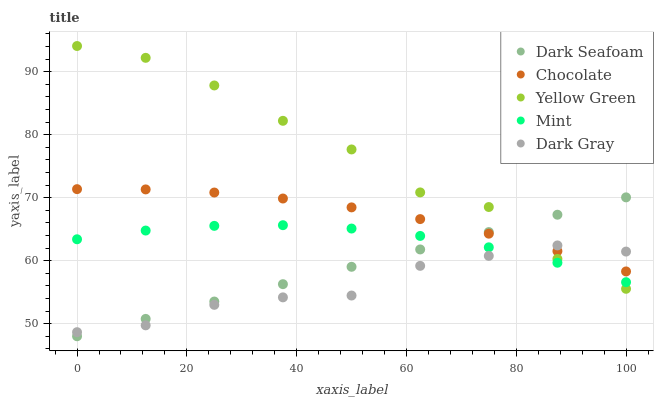Does Dark Gray have the minimum area under the curve?
Answer yes or no. Yes. Does Yellow Green have the maximum area under the curve?
Answer yes or no. Yes. Does Dark Seafoam have the minimum area under the curve?
Answer yes or no. No. Does Dark Seafoam have the maximum area under the curve?
Answer yes or no. No. Is Dark Seafoam the smoothest?
Answer yes or no. Yes. Is Yellow Green the roughest?
Answer yes or no. Yes. Is Mint the smoothest?
Answer yes or no. No. Is Mint the roughest?
Answer yes or no. No. Does Dark Seafoam have the lowest value?
Answer yes or no. Yes. Does Mint have the lowest value?
Answer yes or no. No. Does Yellow Green have the highest value?
Answer yes or no. Yes. Does Dark Seafoam have the highest value?
Answer yes or no. No. Is Mint less than Chocolate?
Answer yes or no. Yes. Is Chocolate greater than Mint?
Answer yes or no. Yes. Does Mint intersect Yellow Green?
Answer yes or no. Yes. Is Mint less than Yellow Green?
Answer yes or no. No. Is Mint greater than Yellow Green?
Answer yes or no. No. Does Mint intersect Chocolate?
Answer yes or no. No. 